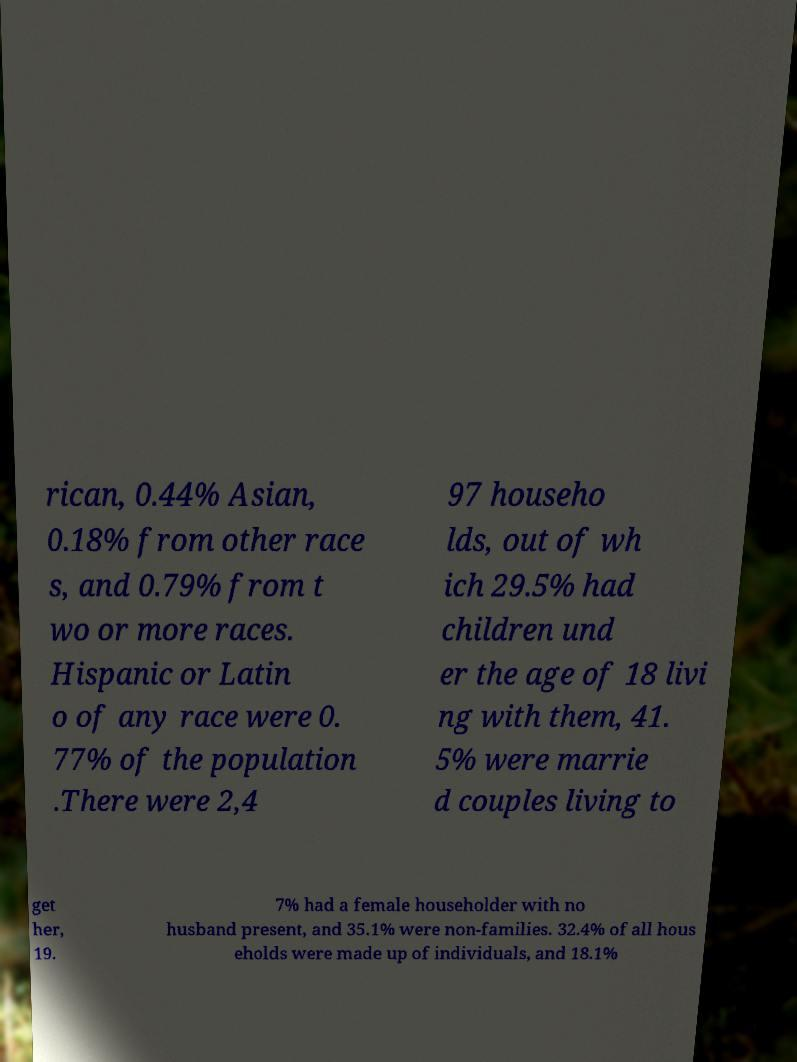Can you accurately transcribe the text from the provided image for me? rican, 0.44% Asian, 0.18% from other race s, and 0.79% from t wo or more races. Hispanic or Latin o of any race were 0. 77% of the population .There were 2,4 97 househo lds, out of wh ich 29.5% had children und er the age of 18 livi ng with them, 41. 5% were marrie d couples living to get her, 19. 7% had a female householder with no husband present, and 35.1% were non-families. 32.4% of all hous eholds were made up of individuals, and 18.1% 